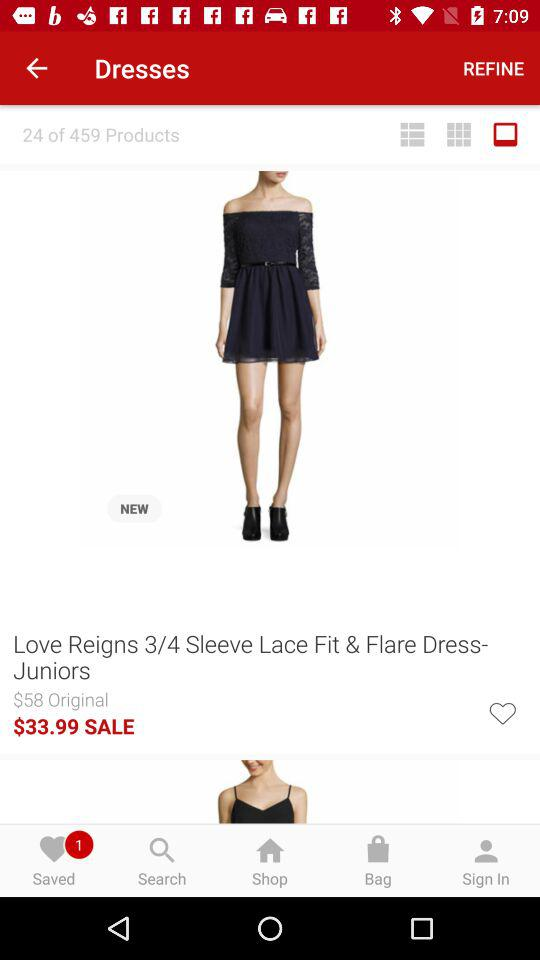How many saved dresses are there? There is 1 saved dress. 